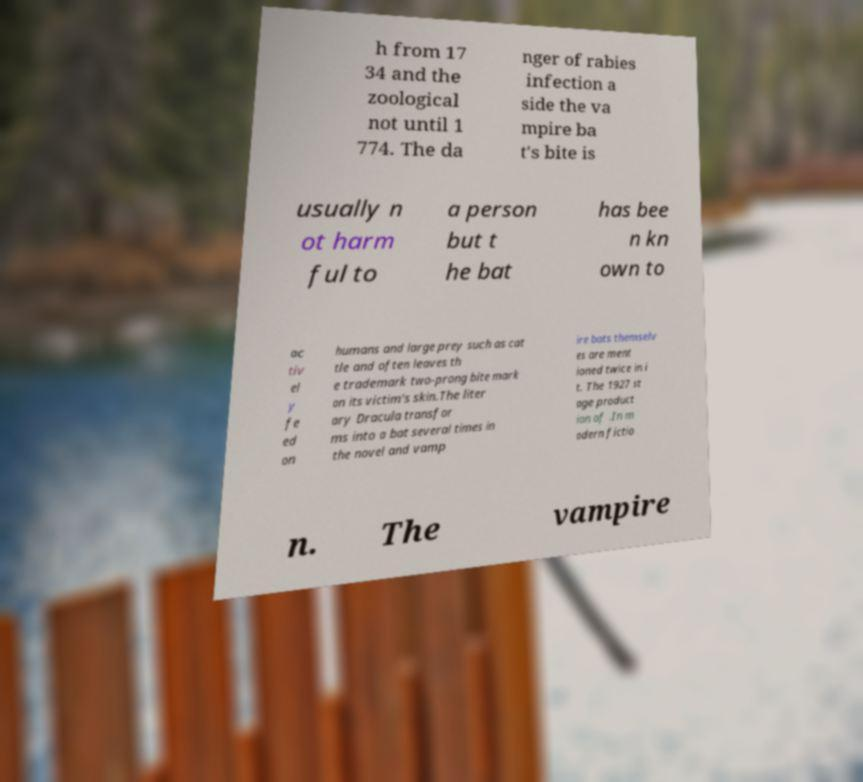Can you read and provide the text displayed in the image?This photo seems to have some interesting text. Can you extract and type it out for me? h from 17 34 and the zoological not until 1 774. The da nger of rabies infection a side the va mpire ba t's bite is usually n ot harm ful to a person but t he bat has bee n kn own to ac tiv el y fe ed on humans and large prey such as cat tle and often leaves th e trademark two-prong bite mark on its victim's skin.The liter ary Dracula transfor ms into a bat several times in the novel and vamp ire bats themselv es are ment ioned twice in i t. The 1927 st age product ion of .In m odern fictio n. The vampire 